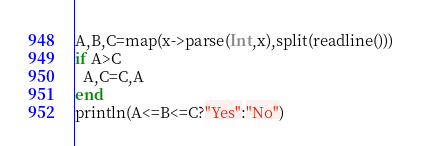Convert code to text. <code><loc_0><loc_0><loc_500><loc_500><_Julia_>A,B,C=map(x->parse(Int,x),split(readline()))
if A>C
  A,C=C,A
end
println(A<=B<=C?"Yes":"No")</code> 